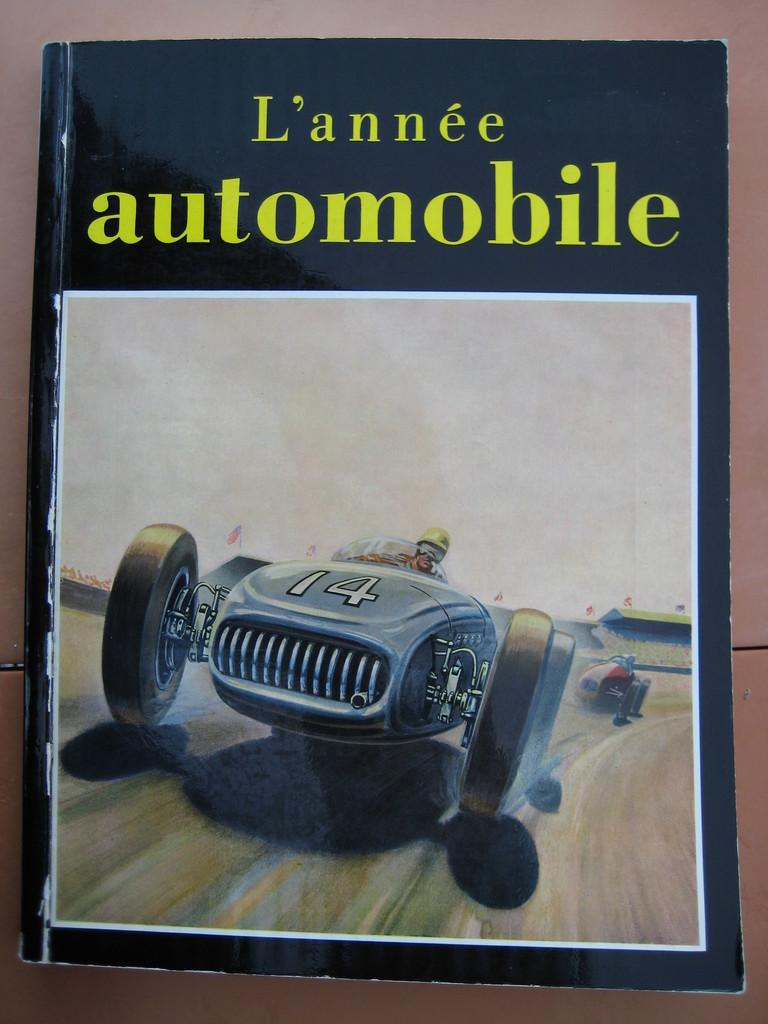What object is present in the image that is related to reading or learning? There is a book in the image. What is depicted on the cover of the book? The book has a picture of vehicles on its cover. What else can be seen on the book besides the picture? There is text written on the book. What type of soup is being served in the image? There is no soup present in the image; it features a book with a picture of vehicles. What class is the governor attending in the image? There is no class or governor present in the image. 